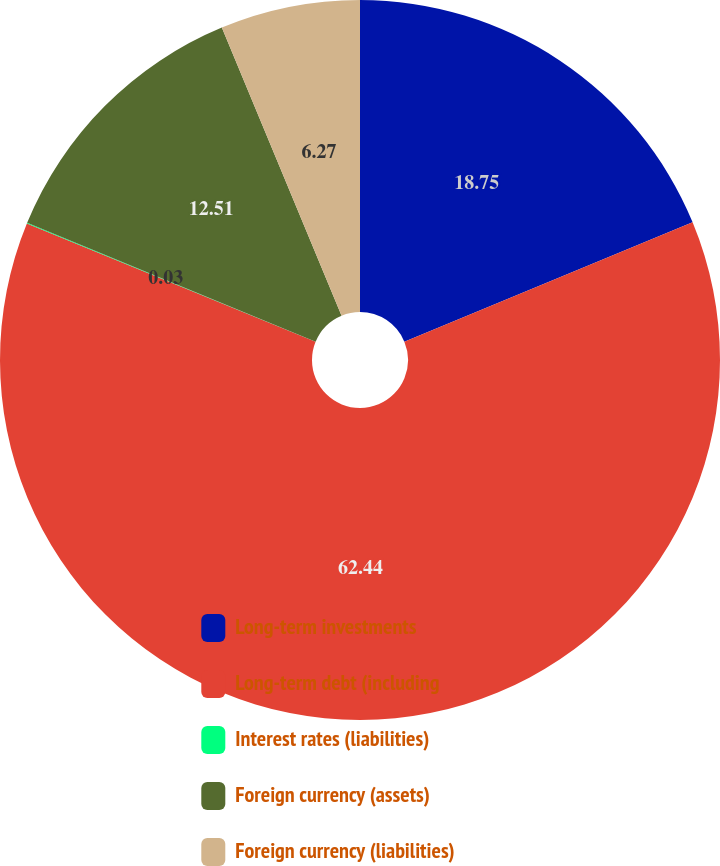<chart> <loc_0><loc_0><loc_500><loc_500><pie_chart><fcel>Long-term investments<fcel>Long-term debt (including<fcel>Interest rates (liabilities)<fcel>Foreign currency (assets)<fcel>Foreign currency (liabilities)<nl><fcel>18.75%<fcel>62.44%<fcel>0.03%<fcel>12.51%<fcel>6.27%<nl></chart> 